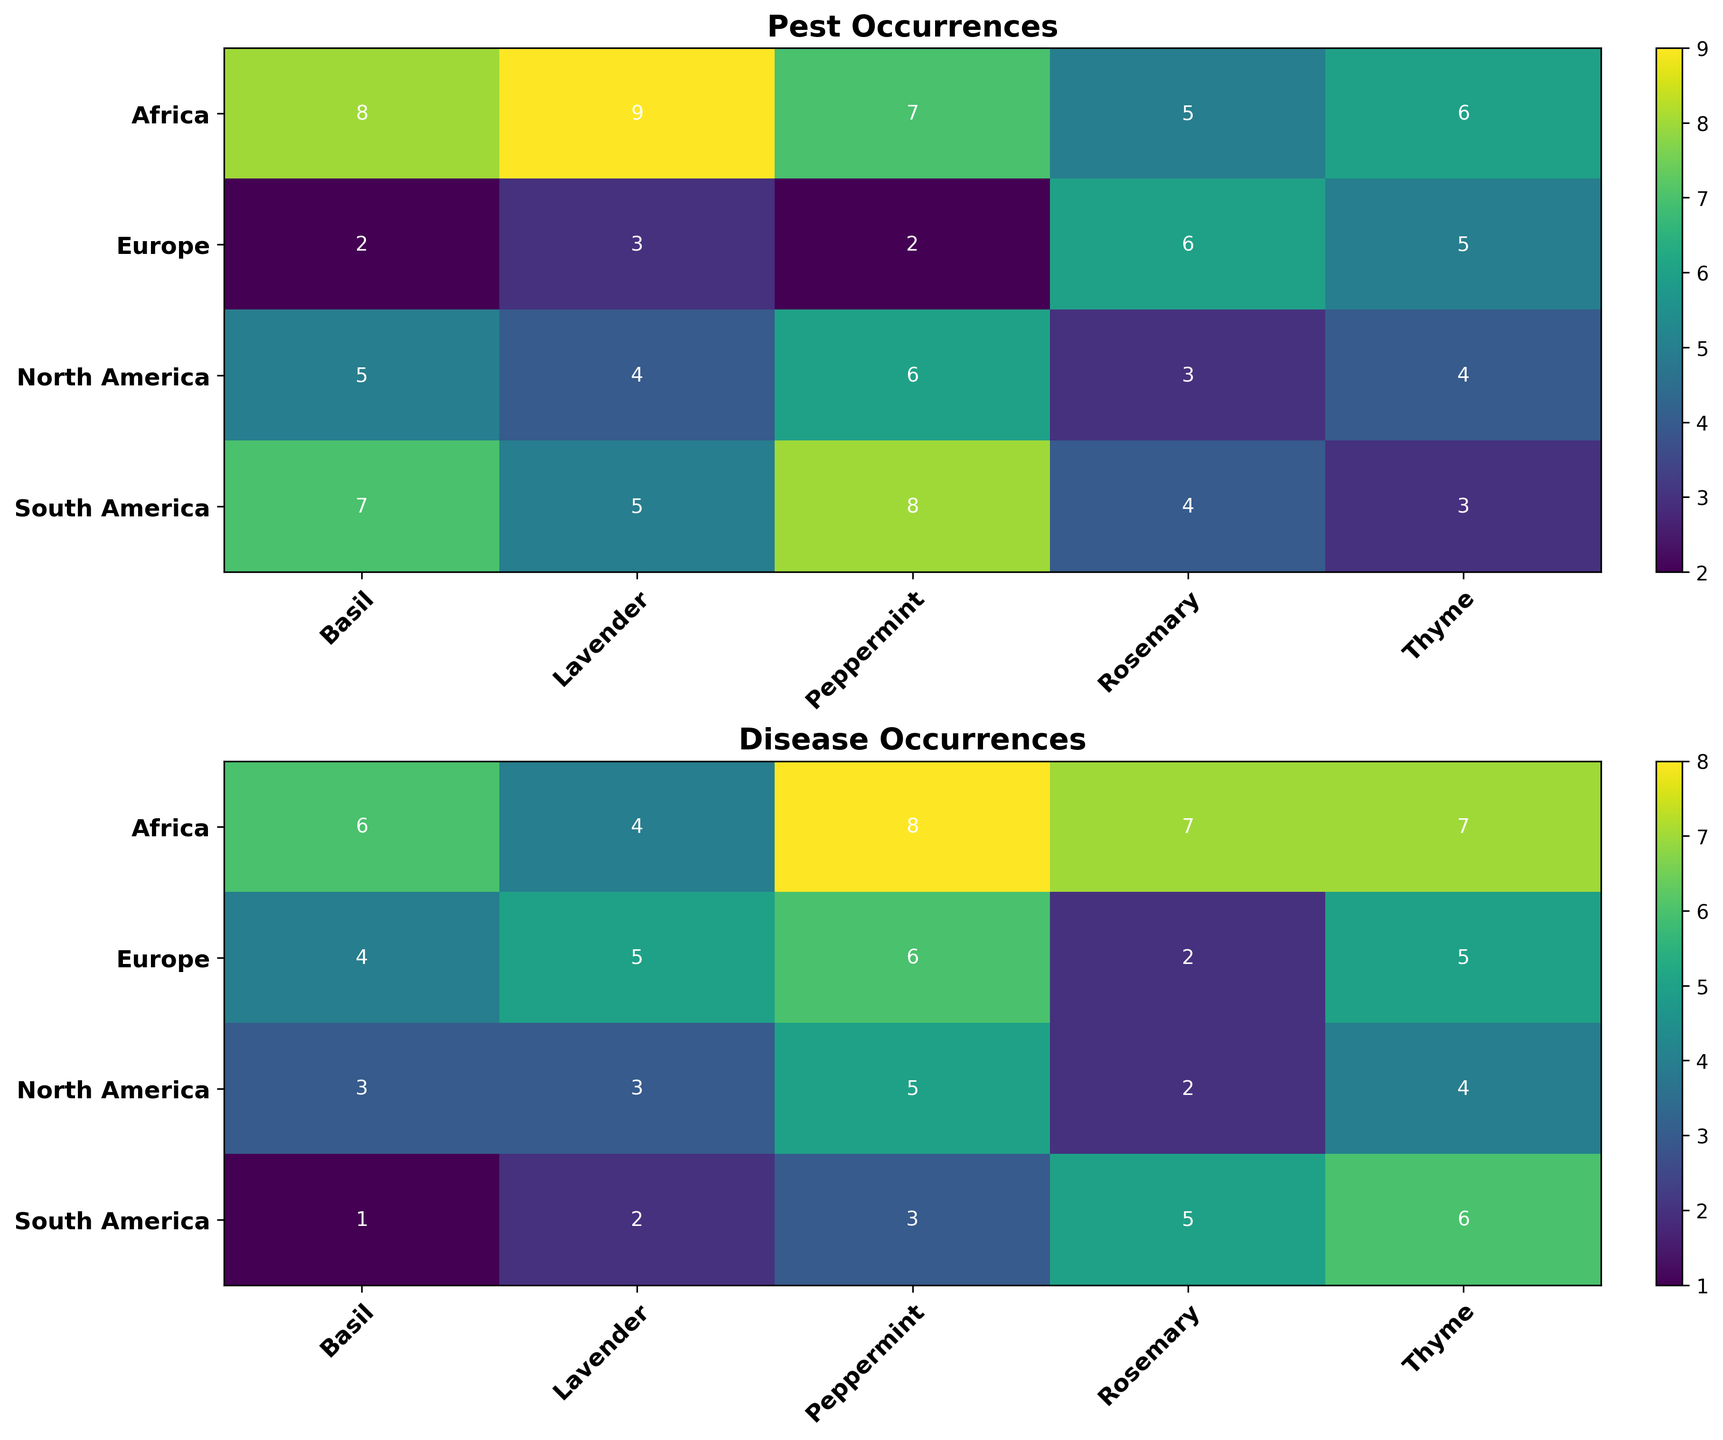Which region has the highest number of pest occurrences for Basil? Look at the heatmap for Pest Occurrences, find the row labeled "Basil," and then find the region with the highest numerical value
Answer: Africa Which plant species has the least number of disease occurrences in South America? Look at the heatmap for Disease Occurrences, find the row labeled "South America," and then identify the lowest numerical value and the corresponding plant species
Answer: Basil What's the difference between pest occurrences for Rosemary in North America and South America? Locate Rosemary's row in the Pest Occurrences heatmap, then subtract the value for North America from the value for South America (4 - 3)
Answer: 1 Which plant species and region combination has the highest pest occurrences overall? Scan the Pest Occurrences heatmap for the highest numerical value and identify the plant species and region combination
Answer: Lavender in Africa Among all regions, which one has the highest average disease occurrences for all plant species? For each region, sum the Disease Occurrences for all plant species and then divide by the number of plant species; find the highest average
Answer: Africa Is there a plant species that has consistently high (5 or above) pest occurrences across all regions? Check each row in the Pest Occurrences heatmap, if all values for all regions for a specific plant are 5 or above
Answer: No Which has a higher pest occurrence in Europe, Peppermint or Thyme? Compare the values for Peppermint and Thyme in the Europe row of the Pest Occurrences heatmap (2 vs. 5)
Answer: Thyme What is the combined total of disease occurrences for Basil in Europe and Africa? Add the Disease Occurrences values for Basil in Europe and Africa (4 + 6)
Answer: 10 Are there any regions where Lavender has fewer pest occurrences than disease occurrences? For each region in Lavender's row, compare the Pest Occurrences heatmap value to the Disease Occurrences heatmap value; if Pest < Disease
Answer: Europe Which plant species has the most balanced pest and disease occurrences, having values that are closest to each other across all regions? Calculate the difference between pest and disease occurrences for each species in each region, and average these differences; the plant species with the smallest average difference is the answer
Answer: Basil 